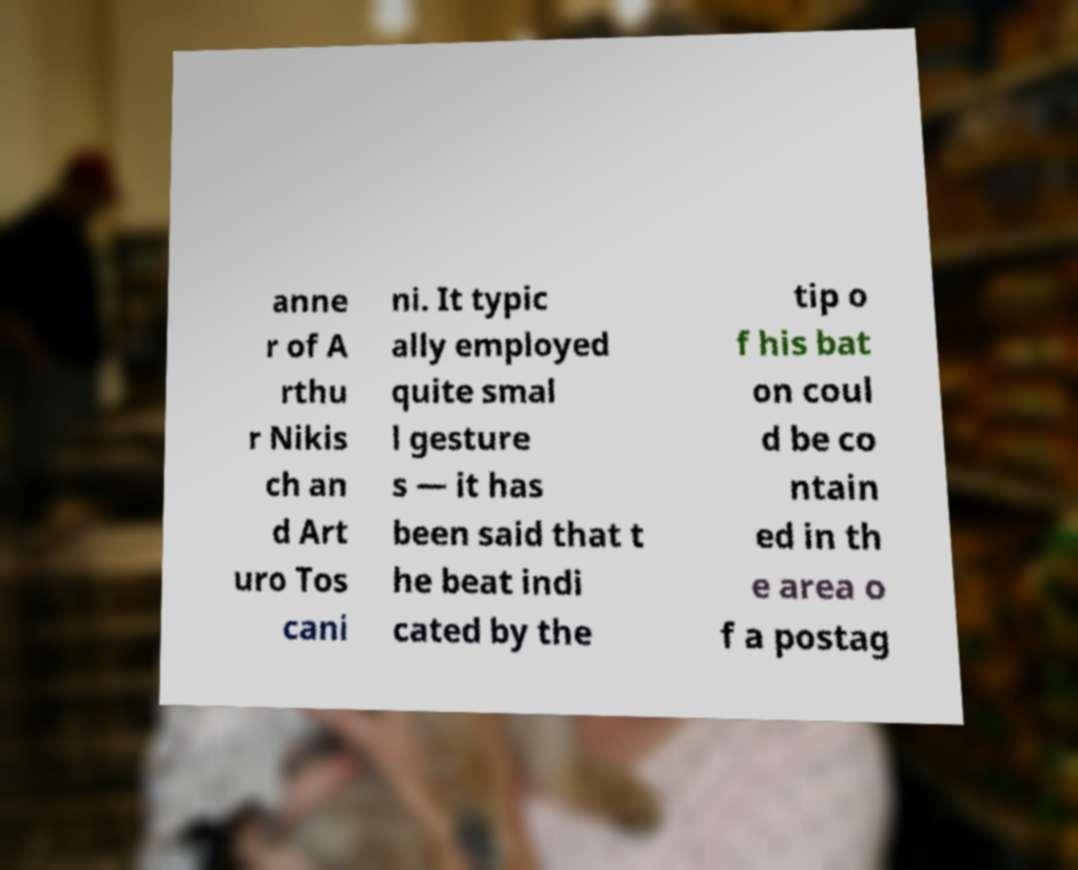I need the written content from this picture converted into text. Can you do that? anne r of A rthu r Nikis ch an d Art uro Tos cani ni. It typic ally employed quite smal l gesture s — it has been said that t he beat indi cated by the tip o f his bat on coul d be co ntain ed in th e area o f a postag 